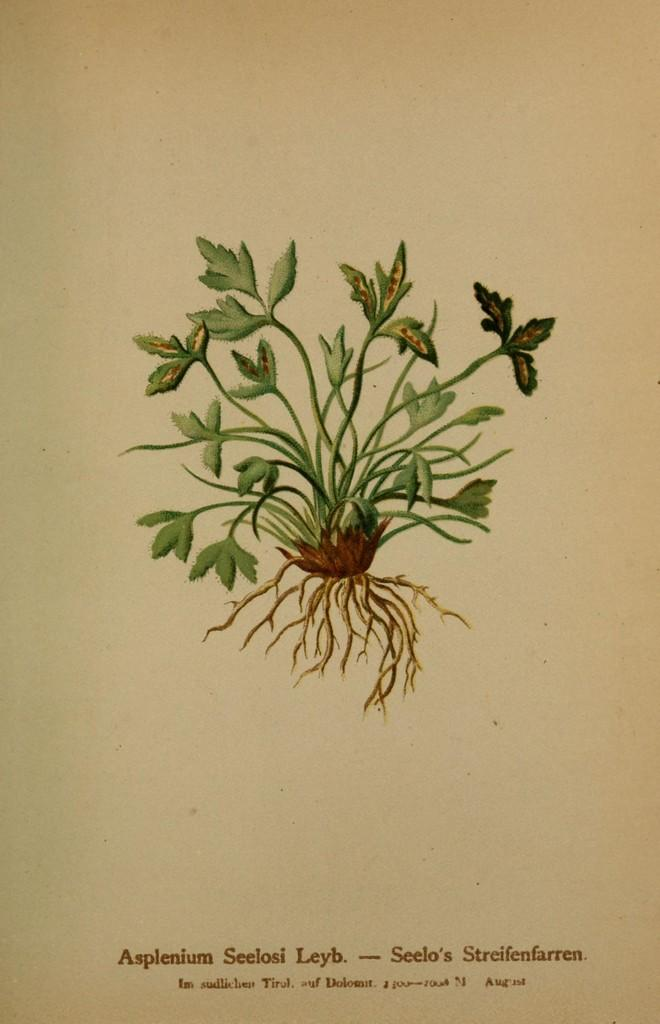What is the medium of the image? The image is on a paper. What is depicted in the image? There is a picture of a plant in the image. Can you describe the plant in the image? The plant has stems, leaves, and roots. What else is present on the paper besides the image? There are letters on the paper. What type of mass can be seen falling from the sky in the image? There is no mass falling from the sky in the image; it only features a picture of a plant and some letters on a paper. Is there any blood visible in the image? No, there is no blood present in the image. 